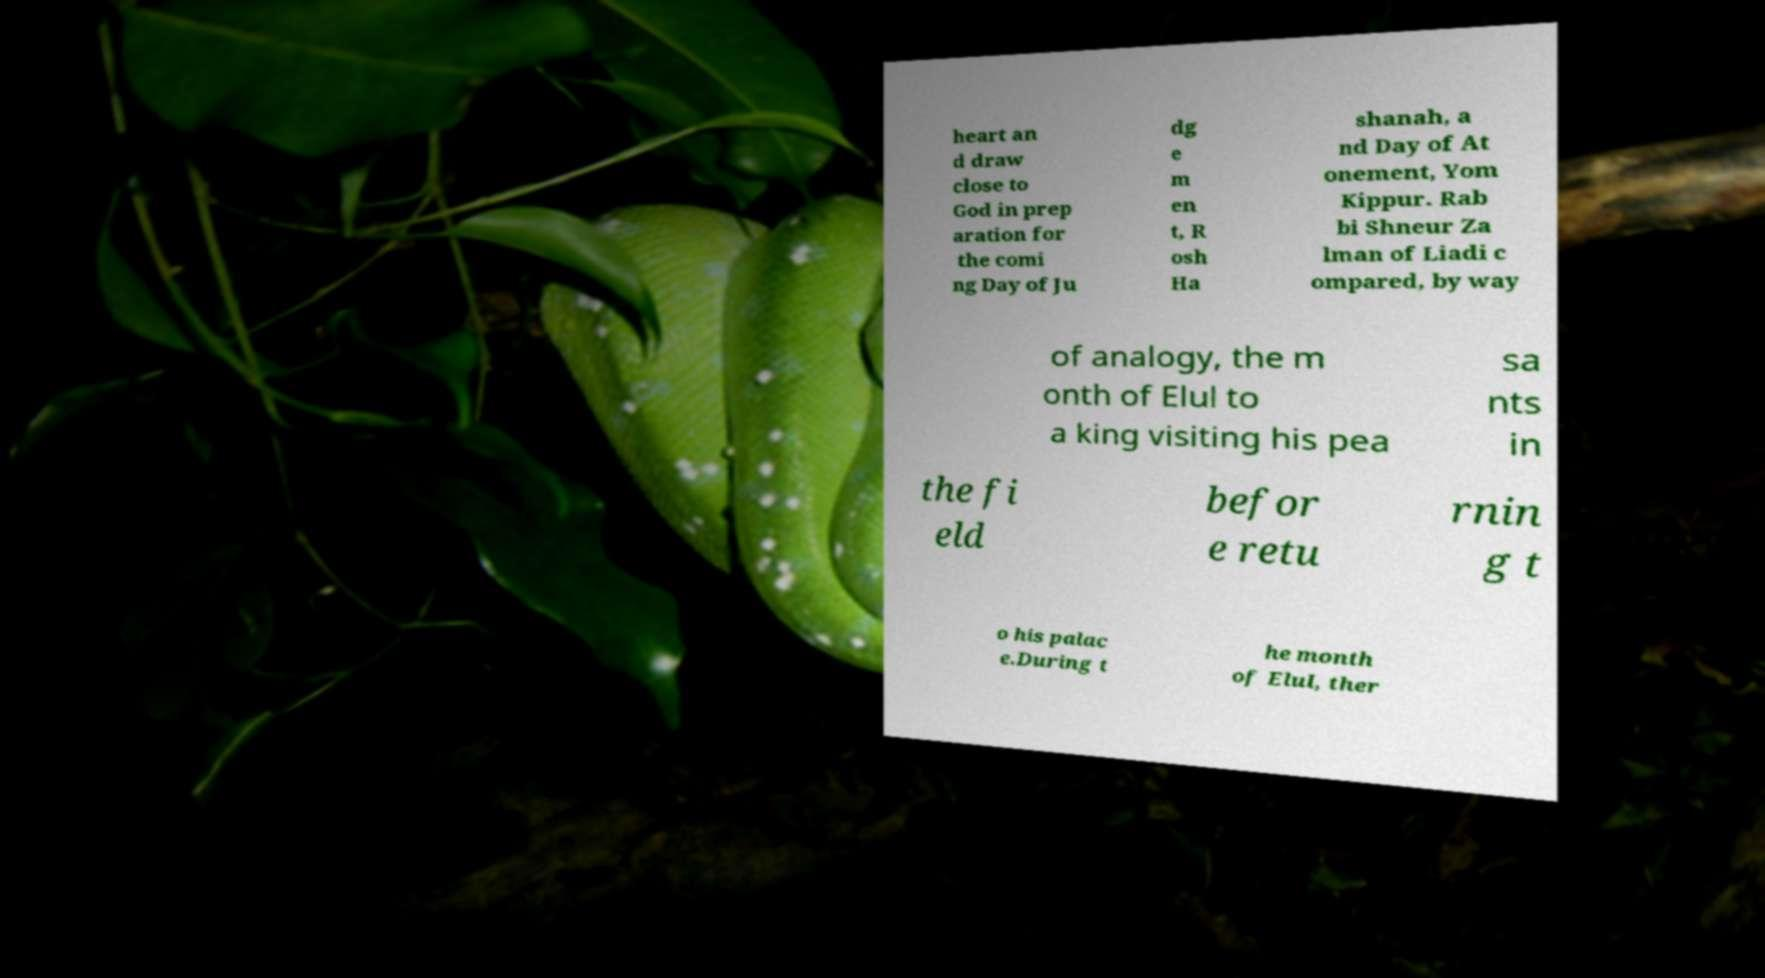There's text embedded in this image that I need extracted. Can you transcribe it verbatim? heart an d draw close to God in prep aration for the comi ng Day of Ju dg e m en t, R osh Ha shanah, a nd Day of At onement, Yom Kippur. Rab bi Shneur Za lman of Liadi c ompared, by way of analogy, the m onth of Elul to a king visiting his pea sa nts in the fi eld befor e retu rnin g t o his palac e.During t he month of Elul, ther 